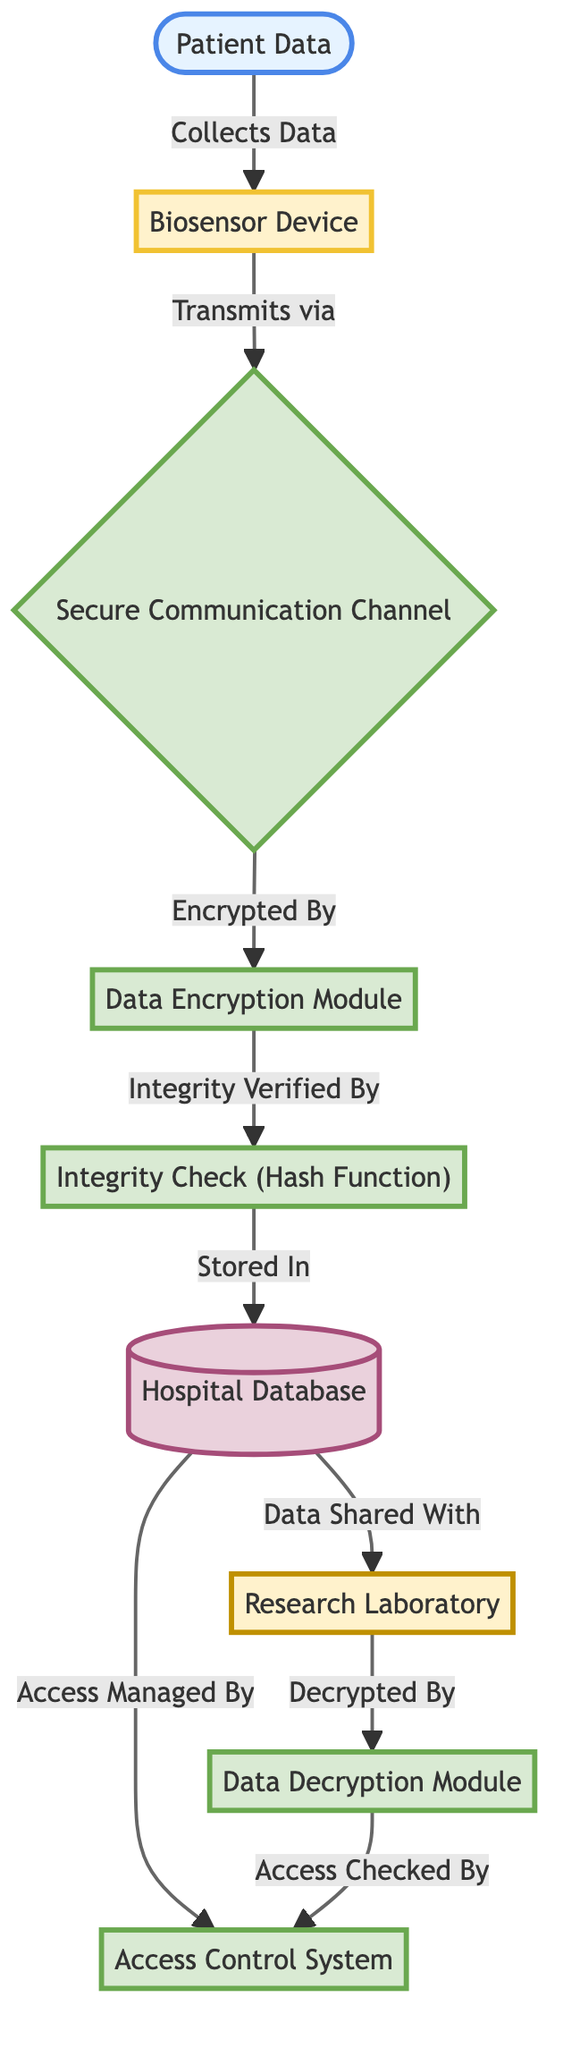What is the first step in the patient data flow? The first step involves the "Patient Data" being collected by the "Biosensor Device," which is the direct connection from patient data to the biosensor device in the diagram.
Answer: Collects Data How many modules handle encryption and integrity verification? The diagram shows two modules related to security: the "Data Encryption Module" and the "Integrity Check (Hash Function)." Thus, there are two modules handling these operations.
Answer: Two What is the purpose of the "Secure Communication Channel"? The "Secure Communication Channel" transmits data securely from the biosensor to the encryption module, ensuring that data is protected during transmission.
Answer: Transmits What is verified after data is encrypted? Following the encryption process, the "Integrity Check (Hash Function)" verifies the integrity of the encrypted data to ensure it has not been tampered with, thus confirming its reliability.
Answer: Integrity Verified Which system manages access to the hospital database? The "Access Control System" is responsible for managing access to the hospital database as indicated in the connection shown in the diagram.
Answer: Access Control System How does data flow from the hospital database to the research lab? The data is shared with the "Research Laboratory" after being stored in the hospital database, which is indicated by the direct flow from the hospital database node to the research lab node.
Answer: Data Shared With Which device collects patient data? The "Biosensor Device" is identified in the diagram as the entity responsible for collecting patient data before any encryption or integrity verification steps take place.
Answer: Biosensor Device What is the final step before the data reaches the research lab? Before the data can be utilized by the research lab, it undergoes decryption by the "Data Decryption Module," which is the final processing step indicated in the diagram before accessing the lab.
Answer: Decrypted By What does the encryption module ensure in the data flow? The "Data Encryption Module" ensures that the patient data is encrypted before it is transmitted, which is a critical step in maintaining confidentiality and security of the data.
Answer: Encrypted By 